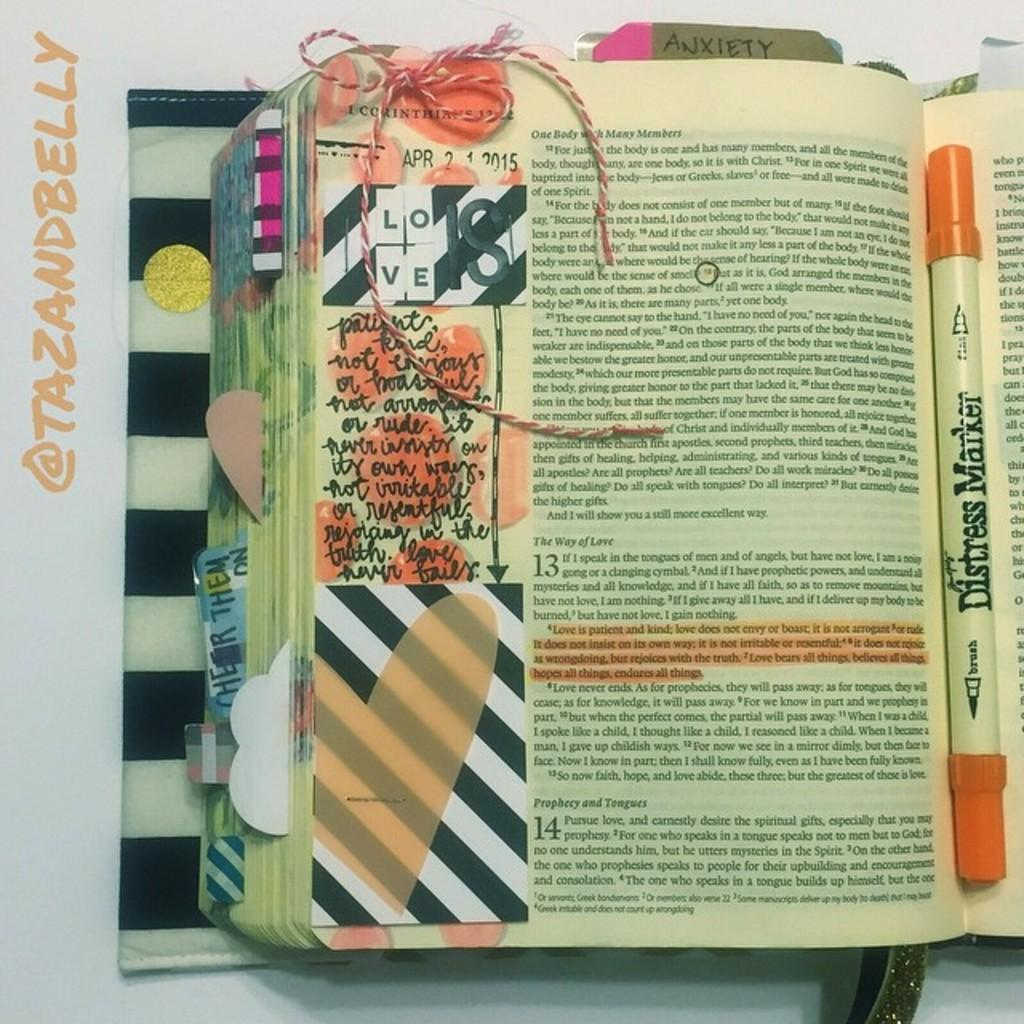<image>
Present a compact description of the photo's key features. An open book has the date 2015 on the side of it. 